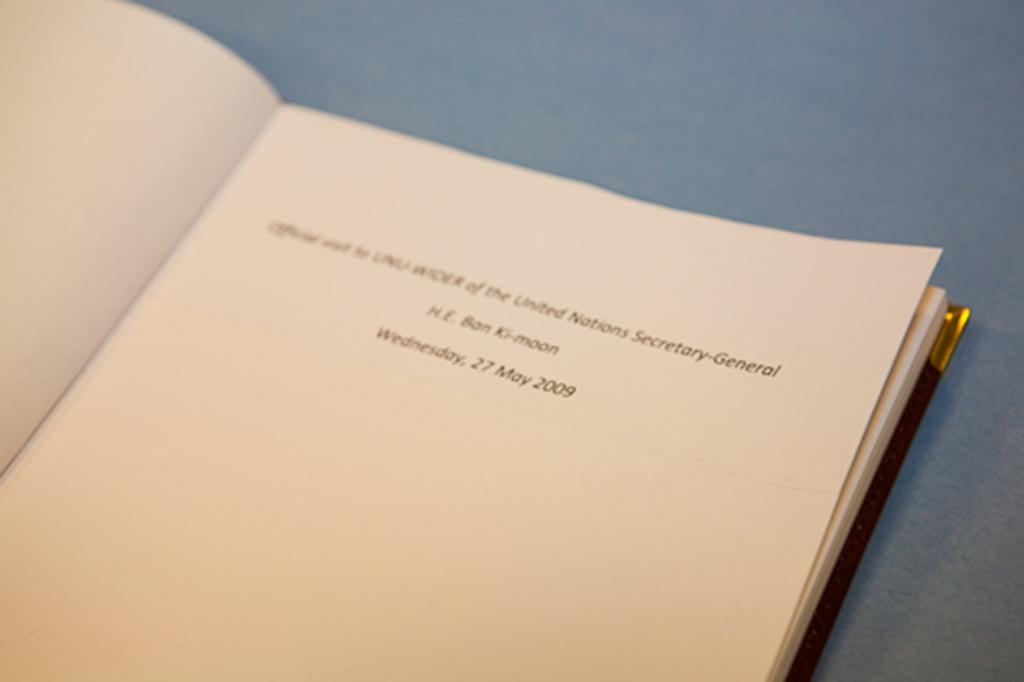<image>
Share a concise interpretation of the image provided. A book is open to the title page and is dated Wednesday, 27 May 2009. 